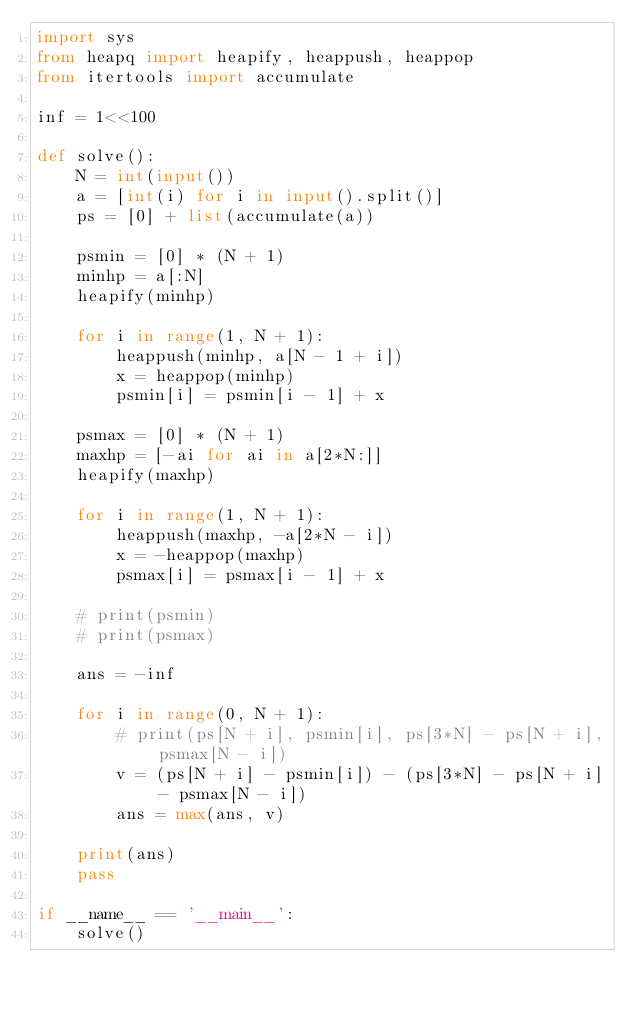Convert code to text. <code><loc_0><loc_0><loc_500><loc_500><_Python_>import sys
from heapq import heapify, heappush, heappop
from itertools import accumulate

inf = 1<<100

def solve():
    N = int(input())
    a = [int(i) for i in input().split()]
    ps = [0] + list(accumulate(a))

    psmin = [0] * (N + 1)
    minhp = a[:N]
    heapify(minhp)

    for i in range(1, N + 1):
        heappush(minhp, a[N - 1 + i])
        x = heappop(minhp)
        psmin[i] = psmin[i - 1] + x

    psmax = [0] * (N + 1)
    maxhp = [-ai for ai in a[2*N:]]
    heapify(maxhp)

    for i in range(1, N + 1):
        heappush(maxhp, -a[2*N - i])
        x = -heappop(maxhp)
        psmax[i] = psmax[i - 1] + x

    # print(psmin)
    # print(psmax)

    ans = -inf

    for i in range(0, N + 1):
        # print(ps[N + i], psmin[i], ps[3*N] - ps[N + i], psmax[N - i])
        v = (ps[N + i] - psmin[i]) - (ps[3*N] - ps[N + i] - psmax[N - i])
        ans = max(ans, v)

    print(ans)
    pass

if __name__ == '__main__':
    solve()</code> 